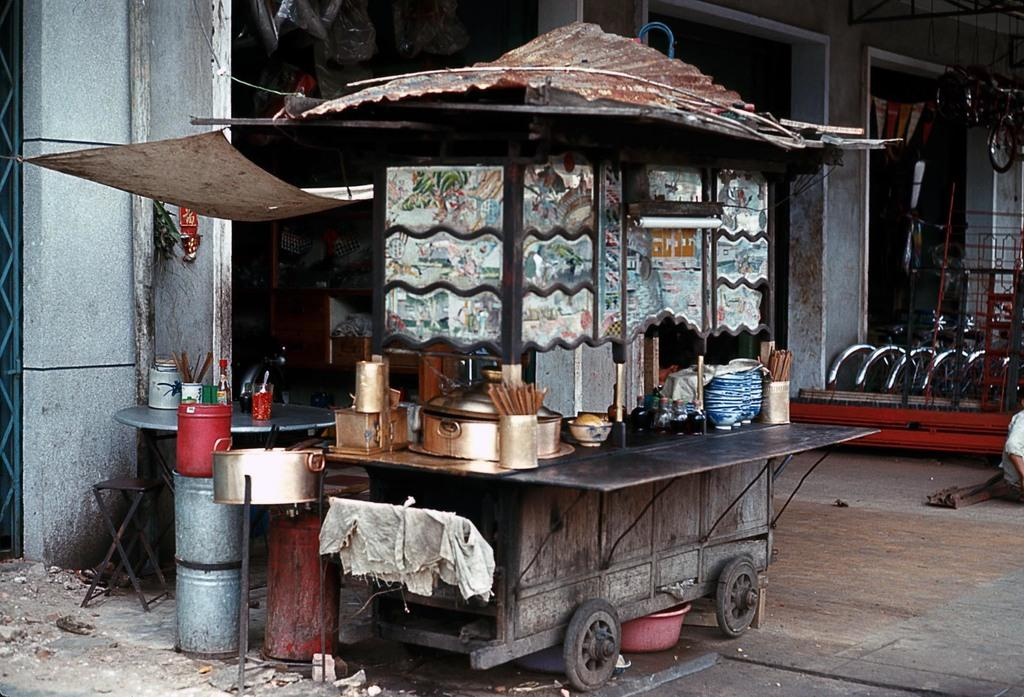What type of establishment is depicted in the image? There is a food court in the image. Can you describe any other businesses or establishments visible in the image? In the background of the image, there is a cycle shop. What statement is being made by the orange in the image? There is no orange present in the image, so no statement can be made by an orange. 